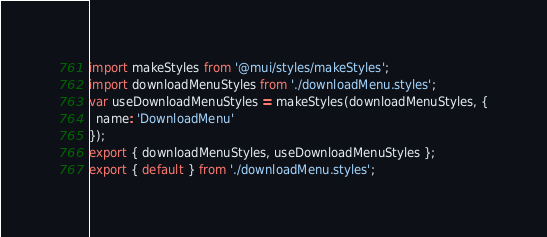Convert code to text. <code><loc_0><loc_0><loc_500><loc_500><_JavaScript_>import makeStyles from '@mui/styles/makeStyles';
import downloadMenuStyles from './downloadMenu.styles';
var useDownloadMenuStyles = makeStyles(downloadMenuStyles, {
  name: 'DownloadMenu'
});
export { downloadMenuStyles, useDownloadMenuStyles };
export { default } from './downloadMenu.styles';</code> 